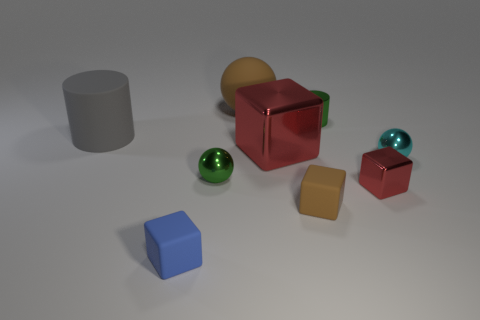Is there anything else that is the same color as the big shiny thing?
Your response must be concise. Yes. Is the large shiny object the same color as the small shiny block?
Ensure brevity in your answer.  Yes. Is the number of large blue rubber cubes less than the number of large red metallic objects?
Offer a very short reply. Yes. There is a gray rubber cylinder; are there any small things in front of it?
Ensure brevity in your answer.  Yes. Are the small cylinder and the small blue cube made of the same material?
Provide a succinct answer. No. What is the color of the other shiny object that is the same shape as the big metal thing?
Offer a very short reply. Red. Does the small sphere left of the big brown matte object have the same color as the small metallic cylinder?
Offer a very short reply. Yes. What shape is the metal thing that is the same color as the small shiny block?
Your answer should be very brief. Cube. How many gray cylinders are the same material as the brown sphere?
Give a very brief answer. 1. There is a large metal cube; what number of red objects are in front of it?
Offer a very short reply. 1. 